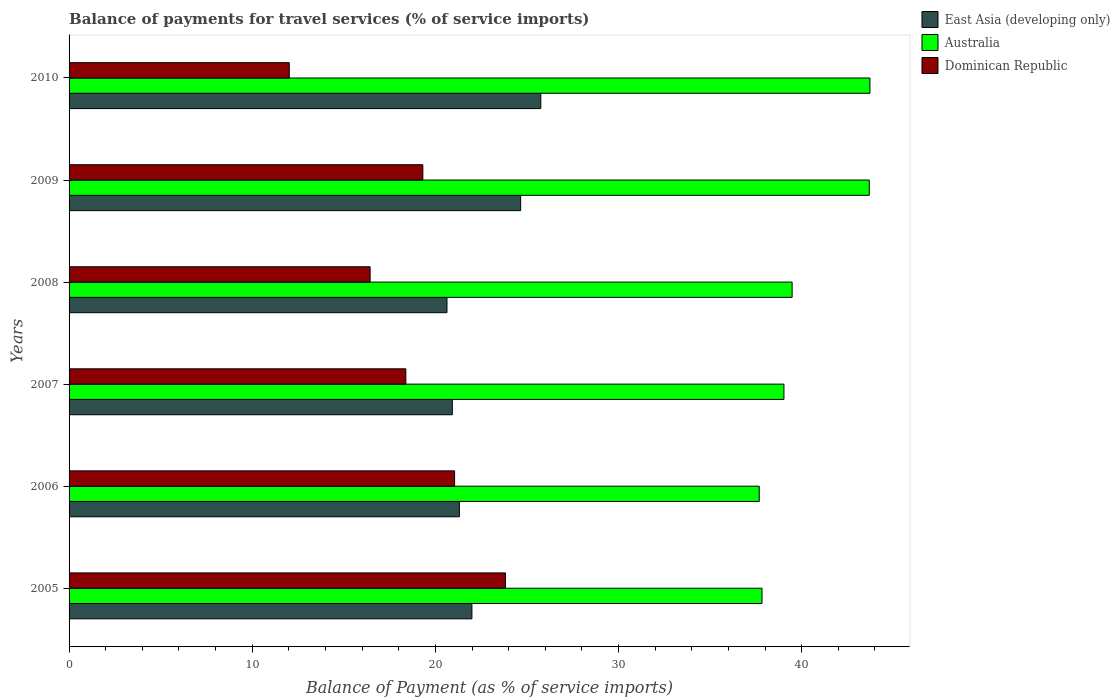Are the number of bars per tick equal to the number of legend labels?
Ensure brevity in your answer.  Yes. How many bars are there on the 1st tick from the top?
Provide a short and direct response. 3. What is the balance of payments for travel services in East Asia (developing only) in 2008?
Provide a short and direct response. 20.63. Across all years, what is the maximum balance of payments for travel services in East Asia (developing only)?
Provide a succinct answer. 25.76. Across all years, what is the minimum balance of payments for travel services in Dominican Republic?
Keep it short and to the point. 12.02. In which year was the balance of payments for travel services in East Asia (developing only) maximum?
Offer a very short reply. 2010. In which year was the balance of payments for travel services in Australia minimum?
Offer a terse response. 2006. What is the total balance of payments for travel services in Australia in the graph?
Your answer should be very brief. 241.44. What is the difference between the balance of payments for travel services in East Asia (developing only) in 2005 and that in 2010?
Your answer should be compact. -3.76. What is the difference between the balance of payments for travel services in Dominican Republic in 2006 and the balance of payments for travel services in East Asia (developing only) in 2007?
Provide a succinct answer. 0.12. What is the average balance of payments for travel services in Dominican Republic per year?
Offer a very short reply. 18.51. In the year 2009, what is the difference between the balance of payments for travel services in East Asia (developing only) and balance of payments for travel services in Australia?
Offer a very short reply. -19.03. What is the ratio of the balance of payments for travel services in East Asia (developing only) in 2009 to that in 2010?
Provide a succinct answer. 0.96. Is the difference between the balance of payments for travel services in East Asia (developing only) in 2009 and 2010 greater than the difference between the balance of payments for travel services in Australia in 2009 and 2010?
Provide a short and direct response. No. What is the difference between the highest and the second highest balance of payments for travel services in Dominican Republic?
Provide a short and direct response. 2.78. What is the difference between the highest and the lowest balance of payments for travel services in East Asia (developing only)?
Provide a short and direct response. 5.12. What does the 3rd bar from the top in 2008 represents?
Provide a succinct answer. East Asia (developing only). What does the 1st bar from the bottom in 2005 represents?
Your response must be concise. East Asia (developing only). Is it the case that in every year, the sum of the balance of payments for travel services in East Asia (developing only) and balance of payments for travel services in Dominican Republic is greater than the balance of payments for travel services in Australia?
Give a very brief answer. No. Does the graph contain grids?
Give a very brief answer. No. How are the legend labels stacked?
Provide a short and direct response. Vertical. What is the title of the graph?
Provide a short and direct response. Balance of payments for travel services (% of service imports). What is the label or title of the X-axis?
Provide a succinct answer. Balance of Payment (as % of service imports). What is the label or title of the Y-axis?
Your response must be concise. Years. What is the Balance of Payment (as % of service imports) of East Asia (developing only) in 2005?
Ensure brevity in your answer.  22. What is the Balance of Payment (as % of service imports) of Australia in 2005?
Offer a very short reply. 37.83. What is the Balance of Payment (as % of service imports) in Dominican Republic in 2005?
Offer a very short reply. 23.83. What is the Balance of Payment (as % of service imports) of East Asia (developing only) in 2006?
Provide a short and direct response. 21.31. What is the Balance of Payment (as % of service imports) in Australia in 2006?
Provide a succinct answer. 37.68. What is the Balance of Payment (as % of service imports) of Dominican Republic in 2006?
Make the answer very short. 21.05. What is the Balance of Payment (as % of service imports) in East Asia (developing only) in 2007?
Provide a short and direct response. 20.93. What is the Balance of Payment (as % of service imports) in Australia in 2007?
Your response must be concise. 39.03. What is the Balance of Payment (as % of service imports) in Dominican Republic in 2007?
Offer a very short reply. 18.39. What is the Balance of Payment (as % of service imports) in East Asia (developing only) in 2008?
Provide a short and direct response. 20.63. What is the Balance of Payment (as % of service imports) of Australia in 2008?
Offer a very short reply. 39.48. What is the Balance of Payment (as % of service imports) in Dominican Republic in 2008?
Ensure brevity in your answer.  16.44. What is the Balance of Payment (as % of service imports) of East Asia (developing only) in 2009?
Make the answer very short. 24.66. What is the Balance of Payment (as % of service imports) in Australia in 2009?
Keep it short and to the point. 43.69. What is the Balance of Payment (as % of service imports) in Dominican Republic in 2009?
Your answer should be very brief. 19.32. What is the Balance of Payment (as % of service imports) of East Asia (developing only) in 2010?
Offer a very short reply. 25.76. What is the Balance of Payment (as % of service imports) in Australia in 2010?
Offer a terse response. 43.73. What is the Balance of Payment (as % of service imports) in Dominican Republic in 2010?
Provide a succinct answer. 12.02. Across all years, what is the maximum Balance of Payment (as % of service imports) of East Asia (developing only)?
Ensure brevity in your answer.  25.76. Across all years, what is the maximum Balance of Payment (as % of service imports) of Australia?
Provide a succinct answer. 43.73. Across all years, what is the maximum Balance of Payment (as % of service imports) in Dominican Republic?
Ensure brevity in your answer.  23.83. Across all years, what is the minimum Balance of Payment (as % of service imports) in East Asia (developing only)?
Keep it short and to the point. 20.63. Across all years, what is the minimum Balance of Payment (as % of service imports) in Australia?
Ensure brevity in your answer.  37.68. Across all years, what is the minimum Balance of Payment (as % of service imports) of Dominican Republic?
Ensure brevity in your answer.  12.02. What is the total Balance of Payment (as % of service imports) in East Asia (developing only) in the graph?
Provide a short and direct response. 135.28. What is the total Balance of Payment (as % of service imports) in Australia in the graph?
Provide a succinct answer. 241.44. What is the total Balance of Payment (as % of service imports) of Dominican Republic in the graph?
Make the answer very short. 111.04. What is the difference between the Balance of Payment (as % of service imports) of East Asia (developing only) in 2005 and that in 2006?
Provide a succinct answer. 0.69. What is the difference between the Balance of Payment (as % of service imports) in Australia in 2005 and that in 2006?
Keep it short and to the point. 0.15. What is the difference between the Balance of Payment (as % of service imports) of Dominican Republic in 2005 and that in 2006?
Keep it short and to the point. 2.78. What is the difference between the Balance of Payment (as % of service imports) of East Asia (developing only) in 2005 and that in 2007?
Keep it short and to the point. 1.07. What is the difference between the Balance of Payment (as % of service imports) of Australia in 2005 and that in 2007?
Your response must be concise. -1.2. What is the difference between the Balance of Payment (as % of service imports) in Dominican Republic in 2005 and that in 2007?
Your answer should be compact. 5.44. What is the difference between the Balance of Payment (as % of service imports) of East Asia (developing only) in 2005 and that in 2008?
Provide a succinct answer. 1.36. What is the difference between the Balance of Payment (as % of service imports) of Australia in 2005 and that in 2008?
Provide a succinct answer. -1.64. What is the difference between the Balance of Payment (as % of service imports) in Dominican Republic in 2005 and that in 2008?
Offer a very short reply. 7.39. What is the difference between the Balance of Payment (as % of service imports) of East Asia (developing only) in 2005 and that in 2009?
Offer a very short reply. -2.66. What is the difference between the Balance of Payment (as % of service imports) in Australia in 2005 and that in 2009?
Give a very brief answer. -5.86. What is the difference between the Balance of Payment (as % of service imports) in Dominican Republic in 2005 and that in 2009?
Make the answer very short. 4.51. What is the difference between the Balance of Payment (as % of service imports) in East Asia (developing only) in 2005 and that in 2010?
Keep it short and to the point. -3.76. What is the difference between the Balance of Payment (as % of service imports) in Australia in 2005 and that in 2010?
Your answer should be very brief. -5.89. What is the difference between the Balance of Payment (as % of service imports) of Dominican Republic in 2005 and that in 2010?
Your answer should be compact. 11.8. What is the difference between the Balance of Payment (as % of service imports) in East Asia (developing only) in 2006 and that in 2007?
Make the answer very short. 0.38. What is the difference between the Balance of Payment (as % of service imports) of Australia in 2006 and that in 2007?
Your response must be concise. -1.35. What is the difference between the Balance of Payment (as % of service imports) in Dominican Republic in 2006 and that in 2007?
Make the answer very short. 2.66. What is the difference between the Balance of Payment (as % of service imports) of East Asia (developing only) in 2006 and that in 2008?
Your answer should be compact. 0.68. What is the difference between the Balance of Payment (as % of service imports) in Australia in 2006 and that in 2008?
Keep it short and to the point. -1.8. What is the difference between the Balance of Payment (as % of service imports) of Dominican Republic in 2006 and that in 2008?
Offer a terse response. 4.61. What is the difference between the Balance of Payment (as % of service imports) of East Asia (developing only) in 2006 and that in 2009?
Keep it short and to the point. -3.35. What is the difference between the Balance of Payment (as % of service imports) in Australia in 2006 and that in 2009?
Make the answer very short. -6.01. What is the difference between the Balance of Payment (as % of service imports) in Dominican Republic in 2006 and that in 2009?
Your response must be concise. 1.73. What is the difference between the Balance of Payment (as % of service imports) of East Asia (developing only) in 2006 and that in 2010?
Your response must be concise. -4.45. What is the difference between the Balance of Payment (as % of service imports) of Australia in 2006 and that in 2010?
Keep it short and to the point. -6.04. What is the difference between the Balance of Payment (as % of service imports) of Dominican Republic in 2006 and that in 2010?
Give a very brief answer. 9.03. What is the difference between the Balance of Payment (as % of service imports) of East Asia (developing only) in 2007 and that in 2008?
Your response must be concise. 0.29. What is the difference between the Balance of Payment (as % of service imports) in Australia in 2007 and that in 2008?
Ensure brevity in your answer.  -0.45. What is the difference between the Balance of Payment (as % of service imports) of Dominican Republic in 2007 and that in 2008?
Give a very brief answer. 1.95. What is the difference between the Balance of Payment (as % of service imports) of East Asia (developing only) in 2007 and that in 2009?
Your response must be concise. -3.73. What is the difference between the Balance of Payment (as % of service imports) of Australia in 2007 and that in 2009?
Your answer should be very brief. -4.66. What is the difference between the Balance of Payment (as % of service imports) in Dominican Republic in 2007 and that in 2009?
Your response must be concise. -0.93. What is the difference between the Balance of Payment (as % of service imports) of East Asia (developing only) in 2007 and that in 2010?
Your answer should be very brief. -4.83. What is the difference between the Balance of Payment (as % of service imports) in Australia in 2007 and that in 2010?
Offer a terse response. -4.7. What is the difference between the Balance of Payment (as % of service imports) in Dominican Republic in 2007 and that in 2010?
Your answer should be compact. 6.36. What is the difference between the Balance of Payment (as % of service imports) in East Asia (developing only) in 2008 and that in 2009?
Give a very brief answer. -4.02. What is the difference between the Balance of Payment (as % of service imports) in Australia in 2008 and that in 2009?
Your answer should be very brief. -4.21. What is the difference between the Balance of Payment (as % of service imports) in Dominican Republic in 2008 and that in 2009?
Keep it short and to the point. -2.88. What is the difference between the Balance of Payment (as % of service imports) in East Asia (developing only) in 2008 and that in 2010?
Provide a short and direct response. -5.12. What is the difference between the Balance of Payment (as % of service imports) in Australia in 2008 and that in 2010?
Ensure brevity in your answer.  -4.25. What is the difference between the Balance of Payment (as % of service imports) of Dominican Republic in 2008 and that in 2010?
Provide a short and direct response. 4.41. What is the difference between the Balance of Payment (as % of service imports) in East Asia (developing only) in 2009 and that in 2010?
Your answer should be compact. -1.1. What is the difference between the Balance of Payment (as % of service imports) in Australia in 2009 and that in 2010?
Keep it short and to the point. -0.04. What is the difference between the Balance of Payment (as % of service imports) of Dominican Republic in 2009 and that in 2010?
Your response must be concise. 7.29. What is the difference between the Balance of Payment (as % of service imports) of East Asia (developing only) in 2005 and the Balance of Payment (as % of service imports) of Australia in 2006?
Your answer should be very brief. -15.69. What is the difference between the Balance of Payment (as % of service imports) in East Asia (developing only) in 2005 and the Balance of Payment (as % of service imports) in Dominican Republic in 2006?
Offer a very short reply. 0.95. What is the difference between the Balance of Payment (as % of service imports) in Australia in 2005 and the Balance of Payment (as % of service imports) in Dominican Republic in 2006?
Offer a very short reply. 16.78. What is the difference between the Balance of Payment (as % of service imports) in East Asia (developing only) in 2005 and the Balance of Payment (as % of service imports) in Australia in 2007?
Offer a terse response. -17.04. What is the difference between the Balance of Payment (as % of service imports) of East Asia (developing only) in 2005 and the Balance of Payment (as % of service imports) of Dominican Republic in 2007?
Give a very brief answer. 3.61. What is the difference between the Balance of Payment (as % of service imports) in Australia in 2005 and the Balance of Payment (as % of service imports) in Dominican Republic in 2007?
Provide a succinct answer. 19.45. What is the difference between the Balance of Payment (as % of service imports) of East Asia (developing only) in 2005 and the Balance of Payment (as % of service imports) of Australia in 2008?
Provide a short and direct response. -17.48. What is the difference between the Balance of Payment (as % of service imports) in East Asia (developing only) in 2005 and the Balance of Payment (as % of service imports) in Dominican Republic in 2008?
Your answer should be very brief. 5.56. What is the difference between the Balance of Payment (as % of service imports) of Australia in 2005 and the Balance of Payment (as % of service imports) of Dominican Republic in 2008?
Provide a succinct answer. 21.4. What is the difference between the Balance of Payment (as % of service imports) of East Asia (developing only) in 2005 and the Balance of Payment (as % of service imports) of Australia in 2009?
Give a very brief answer. -21.69. What is the difference between the Balance of Payment (as % of service imports) in East Asia (developing only) in 2005 and the Balance of Payment (as % of service imports) in Dominican Republic in 2009?
Make the answer very short. 2.68. What is the difference between the Balance of Payment (as % of service imports) in Australia in 2005 and the Balance of Payment (as % of service imports) in Dominican Republic in 2009?
Give a very brief answer. 18.52. What is the difference between the Balance of Payment (as % of service imports) in East Asia (developing only) in 2005 and the Balance of Payment (as % of service imports) in Australia in 2010?
Offer a terse response. -21.73. What is the difference between the Balance of Payment (as % of service imports) in East Asia (developing only) in 2005 and the Balance of Payment (as % of service imports) in Dominican Republic in 2010?
Provide a short and direct response. 9.97. What is the difference between the Balance of Payment (as % of service imports) of Australia in 2005 and the Balance of Payment (as % of service imports) of Dominican Republic in 2010?
Provide a short and direct response. 25.81. What is the difference between the Balance of Payment (as % of service imports) in East Asia (developing only) in 2006 and the Balance of Payment (as % of service imports) in Australia in 2007?
Provide a succinct answer. -17.72. What is the difference between the Balance of Payment (as % of service imports) in East Asia (developing only) in 2006 and the Balance of Payment (as % of service imports) in Dominican Republic in 2007?
Your response must be concise. 2.92. What is the difference between the Balance of Payment (as % of service imports) in Australia in 2006 and the Balance of Payment (as % of service imports) in Dominican Republic in 2007?
Ensure brevity in your answer.  19.3. What is the difference between the Balance of Payment (as % of service imports) in East Asia (developing only) in 2006 and the Balance of Payment (as % of service imports) in Australia in 2008?
Your answer should be compact. -18.17. What is the difference between the Balance of Payment (as % of service imports) of East Asia (developing only) in 2006 and the Balance of Payment (as % of service imports) of Dominican Republic in 2008?
Your answer should be very brief. 4.87. What is the difference between the Balance of Payment (as % of service imports) of Australia in 2006 and the Balance of Payment (as % of service imports) of Dominican Republic in 2008?
Your answer should be very brief. 21.25. What is the difference between the Balance of Payment (as % of service imports) in East Asia (developing only) in 2006 and the Balance of Payment (as % of service imports) in Australia in 2009?
Provide a succinct answer. -22.38. What is the difference between the Balance of Payment (as % of service imports) in East Asia (developing only) in 2006 and the Balance of Payment (as % of service imports) in Dominican Republic in 2009?
Your response must be concise. 1.99. What is the difference between the Balance of Payment (as % of service imports) in Australia in 2006 and the Balance of Payment (as % of service imports) in Dominican Republic in 2009?
Offer a very short reply. 18.37. What is the difference between the Balance of Payment (as % of service imports) in East Asia (developing only) in 2006 and the Balance of Payment (as % of service imports) in Australia in 2010?
Your response must be concise. -22.42. What is the difference between the Balance of Payment (as % of service imports) of East Asia (developing only) in 2006 and the Balance of Payment (as % of service imports) of Dominican Republic in 2010?
Offer a terse response. 9.29. What is the difference between the Balance of Payment (as % of service imports) in Australia in 2006 and the Balance of Payment (as % of service imports) in Dominican Republic in 2010?
Provide a succinct answer. 25.66. What is the difference between the Balance of Payment (as % of service imports) of East Asia (developing only) in 2007 and the Balance of Payment (as % of service imports) of Australia in 2008?
Make the answer very short. -18.55. What is the difference between the Balance of Payment (as % of service imports) of East Asia (developing only) in 2007 and the Balance of Payment (as % of service imports) of Dominican Republic in 2008?
Your answer should be very brief. 4.49. What is the difference between the Balance of Payment (as % of service imports) of Australia in 2007 and the Balance of Payment (as % of service imports) of Dominican Republic in 2008?
Keep it short and to the point. 22.59. What is the difference between the Balance of Payment (as % of service imports) in East Asia (developing only) in 2007 and the Balance of Payment (as % of service imports) in Australia in 2009?
Offer a very short reply. -22.76. What is the difference between the Balance of Payment (as % of service imports) in East Asia (developing only) in 2007 and the Balance of Payment (as % of service imports) in Dominican Republic in 2009?
Ensure brevity in your answer.  1.61. What is the difference between the Balance of Payment (as % of service imports) in Australia in 2007 and the Balance of Payment (as % of service imports) in Dominican Republic in 2009?
Provide a succinct answer. 19.71. What is the difference between the Balance of Payment (as % of service imports) of East Asia (developing only) in 2007 and the Balance of Payment (as % of service imports) of Australia in 2010?
Ensure brevity in your answer.  -22.8. What is the difference between the Balance of Payment (as % of service imports) of East Asia (developing only) in 2007 and the Balance of Payment (as % of service imports) of Dominican Republic in 2010?
Provide a short and direct response. 8.9. What is the difference between the Balance of Payment (as % of service imports) of Australia in 2007 and the Balance of Payment (as % of service imports) of Dominican Republic in 2010?
Provide a short and direct response. 27.01. What is the difference between the Balance of Payment (as % of service imports) in East Asia (developing only) in 2008 and the Balance of Payment (as % of service imports) in Australia in 2009?
Give a very brief answer. -23.06. What is the difference between the Balance of Payment (as % of service imports) in East Asia (developing only) in 2008 and the Balance of Payment (as % of service imports) in Dominican Republic in 2009?
Your answer should be very brief. 1.32. What is the difference between the Balance of Payment (as % of service imports) in Australia in 2008 and the Balance of Payment (as % of service imports) in Dominican Republic in 2009?
Your answer should be compact. 20.16. What is the difference between the Balance of Payment (as % of service imports) in East Asia (developing only) in 2008 and the Balance of Payment (as % of service imports) in Australia in 2010?
Your answer should be very brief. -23.09. What is the difference between the Balance of Payment (as % of service imports) of East Asia (developing only) in 2008 and the Balance of Payment (as % of service imports) of Dominican Republic in 2010?
Your answer should be very brief. 8.61. What is the difference between the Balance of Payment (as % of service imports) in Australia in 2008 and the Balance of Payment (as % of service imports) in Dominican Republic in 2010?
Give a very brief answer. 27.45. What is the difference between the Balance of Payment (as % of service imports) of East Asia (developing only) in 2009 and the Balance of Payment (as % of service imports) of Australia in 2010?
Provide a succinct answer. -19.07. What is the difference between the Balance of Payment (as % of service imports) of East Asia (developing only) in 2009 and the Balance of Payment (as % of service imports) of Dominican Republic in 2010?
Provide a short and direct response. 12.63. What is the difference between the Balance of Payment (as % of service imports) of Australia in 2009 and the Balance of Payment (as % of service imports) of Dominican Republic in 2010?
Keep it short and to the point. 31.67. What is the average Balance of Payment (as % of service imports) of East Asia (developing only) per year?
Your answer should be compact. 22.55. What is the average Balance of Payment (as % of service imports) of Australia per year?
Offer a terse response. 40.24. What is the average Balance of Payment (as % of service imports) in Dominican Republic per year?
Give a very brief answer. 18.51. In the year 2005, what is the difference between the Balance of Payment (as % of service imports) of East Asia (developing only) and Balance of Payment (as % of service imports) of Australia?
Give a very brief answer. -15.84. In the year 2005, what is the difference between the Balance of Payment (as % of service imports) in East Asia (developing only) and Balance of Payment (as % of service imports) in Dominican Republic?
Ensure brevity in your answer.  -1.83. In the year 2005, what is the difference between the Balance of Payment (as % of service imports) in Australia and Balance of Payment (as % of service imports) in Dominican Republic?
Your response must be concise. 14.01. In the year 2006, what is the difference between the Balance of Payment (as % of service imports) in East Asia (developing only) and Balance of Payment (as % of service imports) in Australia?
Provide a short and direct response. -16.37. In the year 2006, what is the difference between the Balance of Payment (as % of service imports) in East Asia (developing only) and Balance of Payment (as % of service imports) in Dominican Republic?
Provide a short and direct response. 0.26. In the year 2006, what is the difference between the Balance of Payment (as % of service imports) in Australia and Balance of Payment (as % of service imports) in Dominican Republic?
Provide a short and direct response. 16.63. In the year 2007, what is the difference between the Balance of Payment (as % of service imports) of East Asia (developing only) and Balance of Payment (as % of service imports) of Australia?
Make the answer very short. -18.11. In the year 2007, what is the difference between the Balance of Payment (as % of service imports) in East Asia (developing only) and Balance of Payment (as % of service imports) in Dominican Republic?
Give a very brief answer. 2.54. In the year 2007, what is the difference between the Balance of Payment (as % of service imports) of Australia and Balance of Payment (as % of service imports) of Dominican Republic?
Your response must be concise. 20.64. In the year 2008, what is the difference between the Balance of Payment (as % of service imports) of East Asia (developing only) and Balance of Payment (as % of service imports) of Australia?
Your answer should be very brief. -18.84. In the year 2008, what is the difference between the Balance of Payment (as % of service imports) in East Asia (developing only) and Balance of Payment (as % of service imports) in Dominican Republic?
Keep it short and to the point. 4.2. In the year 2008, what is the difference between the Balance of Payment (as % of service imports) in Australia and Balance of Payment (as % of service imports) in Dominican Republic?
Ensure brevity in your answer.  23.04. In the year 2009, what is the difference between the Balance of Payment (as % of service imports) in East Asia (developing only) and Balance of Payment (as % of service imports) in Australia?
Your answer should be compact. -19.03. In the year 2009, what is the difference between the Balance of Payment (as % of service imports) in East Asia (developing only) and Balance of Payment (as % of service imports) in Dominican Republic?
Make the answer very short. 5.34. In the year 2009, what is the difference between the Balance of Payment (as % of service imports) in Australia and Balance of Payment (as % of service imports) in Dominican Republic?
Offer a terse response. 24.37. In the year 2010, what is the difference between the Balance of Payment (as % of service imports) in East Asia (developing only) and Balance of Payment (as % of service imports) in Australia?
Provide a short and direct response. -17.97. In the year 2010, what is the difference between the Balance of Payment (as % of service imports) in East Asia (developing only) and Balance of Payment (as % of service imports) in Dominican Republic?
Your answer should be compact. 13.73. In the year 2010, what is the difference between the Balance of Payment (as % of service imports) in Australia and Balance of Payment (as % of service imports) in Dominican Republic?
Offer a terse response. 31.7. What is the ratio of the Balance of Payment (as % of service imports) in East Asia (developing only) in 2005 to that in 2006?
Make the answer very short. 1.03. What is the ratio of the Balance of Payment (as % of service imports) of Dominican Republic in 2005 to that in 2006?
Offer a very short reply. 1.13. What is the ratio of the Balance of Payment (as % of service imports) in East Asia (developing only) in 2005 to that in 2007?
Your response must be concise. 1.05. What is the ratio of the Balance of Payment (as % of service imports) of Australia in 2005 to that in 2007?
Give a very brief answer. 0.97. What is the ratio of the Balance of Payment (as % of service imports) in Dominican Republic in 2005 to that in 2007?
Ensure brevity in your answer.  1.3. What is the ratio of the Balance of Payment (as % of service imports) of East Asia (developing only) in 2005 to that in 2008?
Offer a terse response. 1.07. What is the ratio of the Balance of Payment (as % of service imports) of Australia in 2005 to that in 2008?
Offer a very short reply. 0.96. What is the ratio of the Balance of Payment (as % of service imports) in Dominican Republic in 2005 to that in 2008?
Offer a terse response. 1.45. What is the ratio of the Balance of Payment (as % of service imports) in East Asia (developing only) in 2005 to that in 2009?
Your answer should be very brief. 0.89. What is the ratio of the Balance of Payment (as % of service imports) of Australia in 2005 to that in 2009?
Make the answer very short. 0.87. What is the ratio of the Balance of Payment (as % of service imports) of Dominican Republic in 2005 to that in 2009?
Provide a short and direct response. 1.23. What is the ratio of the Balance of Payment (as % of service imports) of East Asia (developing only) in 2005 to that in 2010?
Offer a very short reply. 0.85. What is the ratio of the Balance of Payment (as % of service imports) of Australia in 2005 to that in 2010?
Offer a very short reply. 0.87. What is the ratio of the Balance of Payment (as % of service imports) of Dominican Republic in 2005 to that in 2010?
Offer a very short reply. 1.98. What is the ratio of the Balance of Payment (as % of service imports) in East Asia (developing only) in 2006 to that in 2007?
Ensure brevity in your answer.  1.02. What is the ratio of the Balance of Payment (as % of service imports) of Australia in 2006 to that in 2007?
Provide a short and direct response. 0.97. What is the ratio of the Balance of Payment (as % of service imports) in Dominican Republic in 2006 to that in 2007?
Make the answer very short. 1.14. What is the ratio of the Balance of Payment (as % of service imports) in East Asia (developing only) in 2006 to that in 2008?
Provide a short and direct response. 1.03. What is the ratio of the Balance of Payment (as % of service imports) of Australia in 2006 to that in 2008?
Ensure brevity in your answer.  0.95. What is the ratio of the Balance of Payment (as % of service imports) of Dominican Republic in 2006 to that in 2008?
Ensure brevity in your answer.  1.28. What is the ratio of the Balance of Payment (as % of service imports) of East Asia (developing only) in 2006 to that in 2009?
Your response must be concise. 0.86. What is the ratio of the Balance of Payment (as % of service imports) in Australia in 2006 to that in 2009?
Offer a terse response. 0.86. What is the ratio of the Balance of Payment (as % of service imports) in Dominican Republic in 2006 to that in 2009?
Your response must be concise. 1.09. What is the ratio of the Balance of Payment (as % of service imports) of East Asia (developing only) in 2006 to that in 2010?
Offer a terse response. 0.83. What is the ratio of the Balance of Payment (as % of service imports) in Australia in 2006 to that in 2010?
Offer a very short reply. 0.86. What is the ratio of the Balance of Payment (as % of service imports) in Dominican Republic in 2006 to that in 2010?
Keep it short and to the point. 1.75. What is the ratio of the Balance of Payment (as % of service imports) in East Asia (developing only) in 2007 to that in 2008?
Your response must be concise. 1.01. What is the ratio of the Balance of Payment (as % of service imports) of Australia in 2007 to that in 2008?
Offer a terse response. 0.99. What is the ratio of the Balance of Payment (as % of service imports) of Dominican Republic in 2007 to that in 2008?
Provide a succinct answer. 1.12. What is the ratio of the Balance of Payment (as % of service imports) in East Asia (developing only) in 2007 to that in 2009?
Keep it short and to the point. 0.85. What is the ratio of the Balance of Payment (as % of service imports) of Australia in 2007 to that in 2009?
Keep it short and to the point. 0.89. What is the ratio of the Balance of Payment (as % of service imports) of Dominican Republic in 2007 to that in 2009?
Make the answer very short. 0.95. What is the ratio of the Balance of Payment (as % of service imports) of East Asia (developing only) in 2007 to that in 2010?
Offer a terse response. 0.81. What is the ratio of the Balance of Payment (as % of service imports) of Australia in 2007 to that in 2010?
Offer a very short reply. 0.89. What is the ratio of the Balance of Payment (as % of service imports) in Dominican Republic in 2007 to that in 2010?
Your answer should be very brief. 1.53. What is the ratio of the Balance of Payment (as % of service imports) of East Asia (developing only) in 2008 to that in 2009?
Give a very brief answer. 0.84. What is the ratio of the Balance of Payment (as % of service imports) in Australia in 2008 to that in 2009?
Keep it short and to the point. 0.9. What is the ratio of the Balance of Payment (as % of service imports) in Dominican Republic in 2008 to that in 2009?
Offer a terse response. 0.85. What is the ratio of the Balance of Payment (as % of service imports) of East Asia (developing only) in 2008 to that in 2010?
Your answer should be compact. 0.8. What is the ratio of the Balance of Payment (as % of service imports) in Australia in 2008 to that in 2010?
Offer a very short reply. 0.9. What is the ratio of the Balance of Payment (as % of service imports) in Dominican Republic in 2008 to that in 2010?
Offer a terse response. 1.37. What is the ratio of the Balance of Payment (as % of service imports) of East Asia (developing only) in 2009 to that in 2010?
Make the answer very short. 0.96. What is the ratio of the Balance of Payment (as % of service imports) of Dominican Republic in 2009 to that in 2010?
Keep it short and to the point. 1.61. What is the difference between the highest and the second highest Balance of Payment (as % of service imports) of East Asia (developing only)?
Your answer should be compact. 1.1. What is the difference between the highest and the second highest Balance of Payment (as % of service imports) of Australia?
Your answer should be compact. 0.04. What is the difference between the highest and the second highest Balance of Payment (as % of service imports) in Dominican Republic?
Your answer should be compact. 2.78. What is the difference between the highest and the lowest Balance of Payment (as % of service imports) in East Asia (developing only)?
Your response must be concise. 5.12. What is the difference between the highest and the lowest Balance of Payment (as % of service imports) in Australia?
Make the answer very short. 6.04. What is the difference between the highest and the lowest Balance of Payment (as % of service imports) in Dominican Republic?
Your response must be concise. 11.8. 